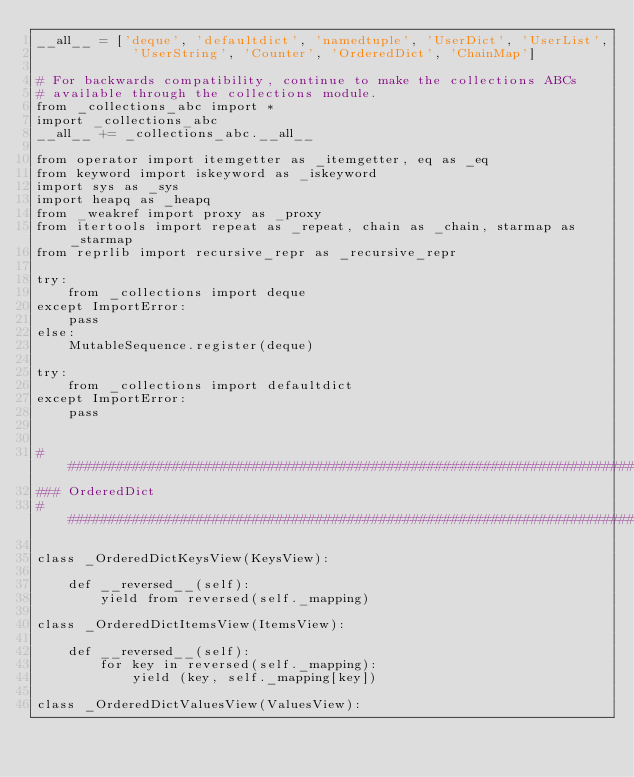Convert code to text. <code><loc_0><loc_0><loc_500><loc_500><_Python_>__all__ = ['deque', 'defaultdict', 'namedtuple', 'UserDict', 'UserList',
            'UserString', 'Counter', 'OrderedDict', 'ChainMap']

# For backwards compatibility, continue to make the collections ABCs
# available through the collections module.
from _collections_abc import *
import _collections_abc
__all__ += _collections_abc.__all__

from operator import itemgetter as _itemgetter, eq as _eq
from keyword import iskeyword as _iskeyword
import sys as _sys
import heapq as _heapq
from _weakref import proxy as _proxy
from itertools import repeat as _repeat, chain as _chain, starmap as _starmap
from reprlib import recursive_repr as _recursive_repr

try:
    from _collections import deque
except ImportError:
    pass
else:
    MutableSequence.register(deque)

try:
    from _collections import defaultdict
except ImportError:
    pass


################################################################################
### OrderedDict
################################################################################

class _OrderedDictKeysView(KeysView):

    def __reversed__(self):
        yield from reversed(self._mapping)

class _OrderedDictItemsView(ItemsView):

    def __reversed__(self):
        for key in reversed(self._mapping):
            yield (key, self._mapping[key])

class _OrderedDictValuesView(ValuesView):
</code> 